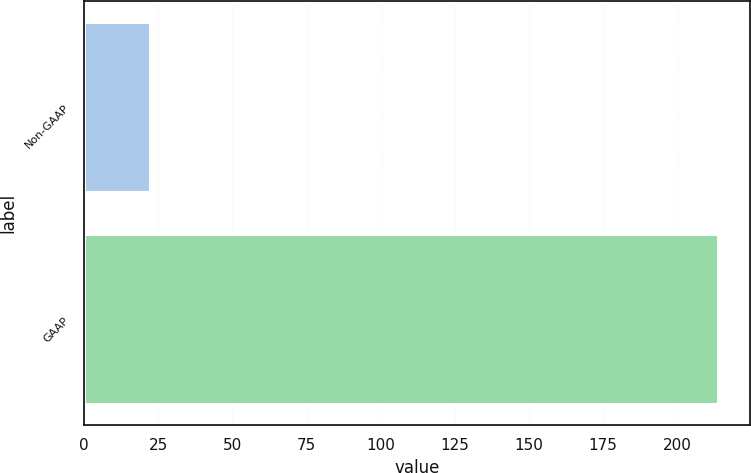Convert chart to OTSL. <chart><loc_0><loc_0><loc_500><loc_500><bar_chart><fcel>Non-GAAP<fcel>GAAP<nl><fcel>22.1<fcel>213.8<nl></chart> 